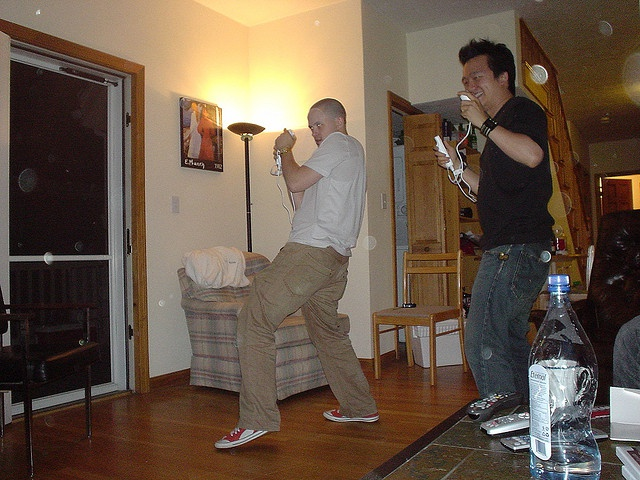Describe the objects in this image and their specific colors. I can see people in gray, black, and maroon tones, people in gray and darkgray tones, couch in gray and black tones, bottle in gray, black, lightgray, and darkgray tones, and chair in gray and black tones in this image. 